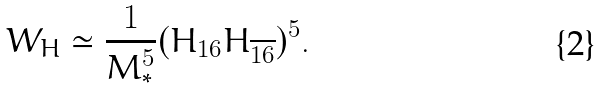<formula> <loc_0><loc_0><loc_500><loc_500>W _ { H } \simeq \frac { 1 } { M _ { * } ^ { 5 } } ( H _ { 1 6 } H _ { \overline { 1 6 } } ) ^ { 5 } .</formula> 